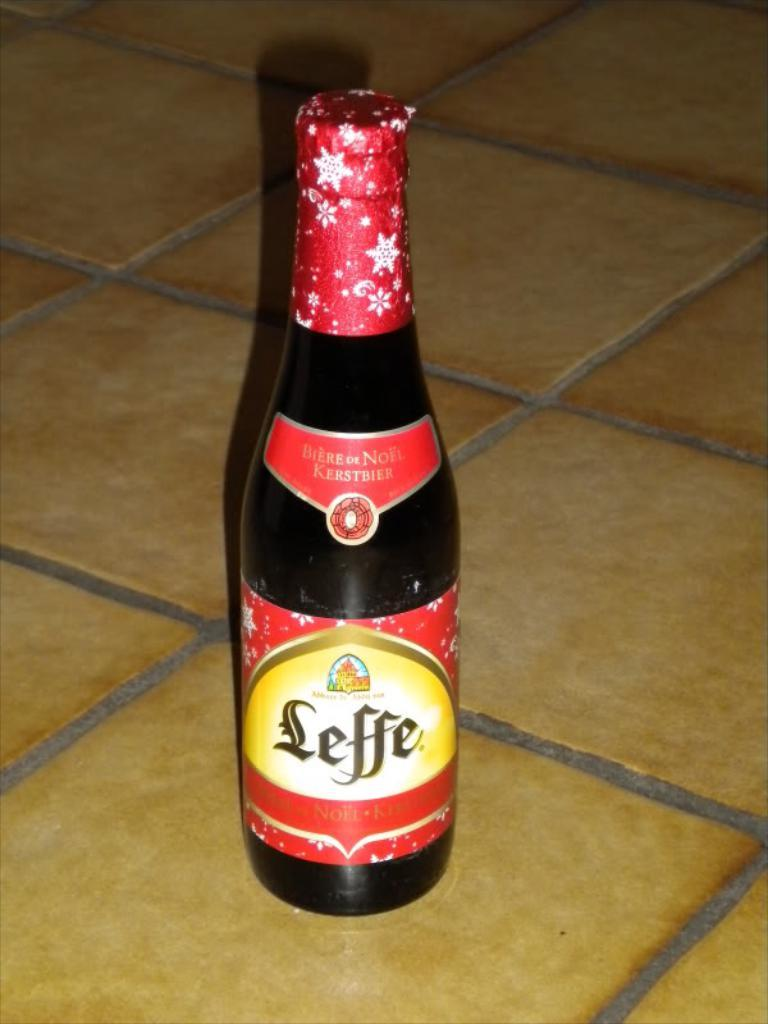<image>
Create a compact narrative representing the image presented. A bottle of Leffe sits on a tiled surface. 